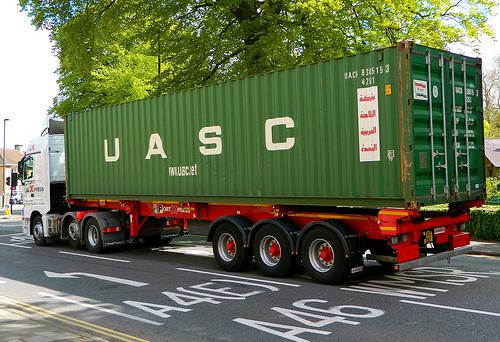Question: what is on the road?
Choices:
A. A car.
B. A van.
C. A station wagon.
D. A truck.
Answer with the letter. Answer: D Question: when is this taken?
Choices:
A. At night.
B. Early morning.
C. During the day.
D. Late evening.
Answer with the letter. Answer: C 